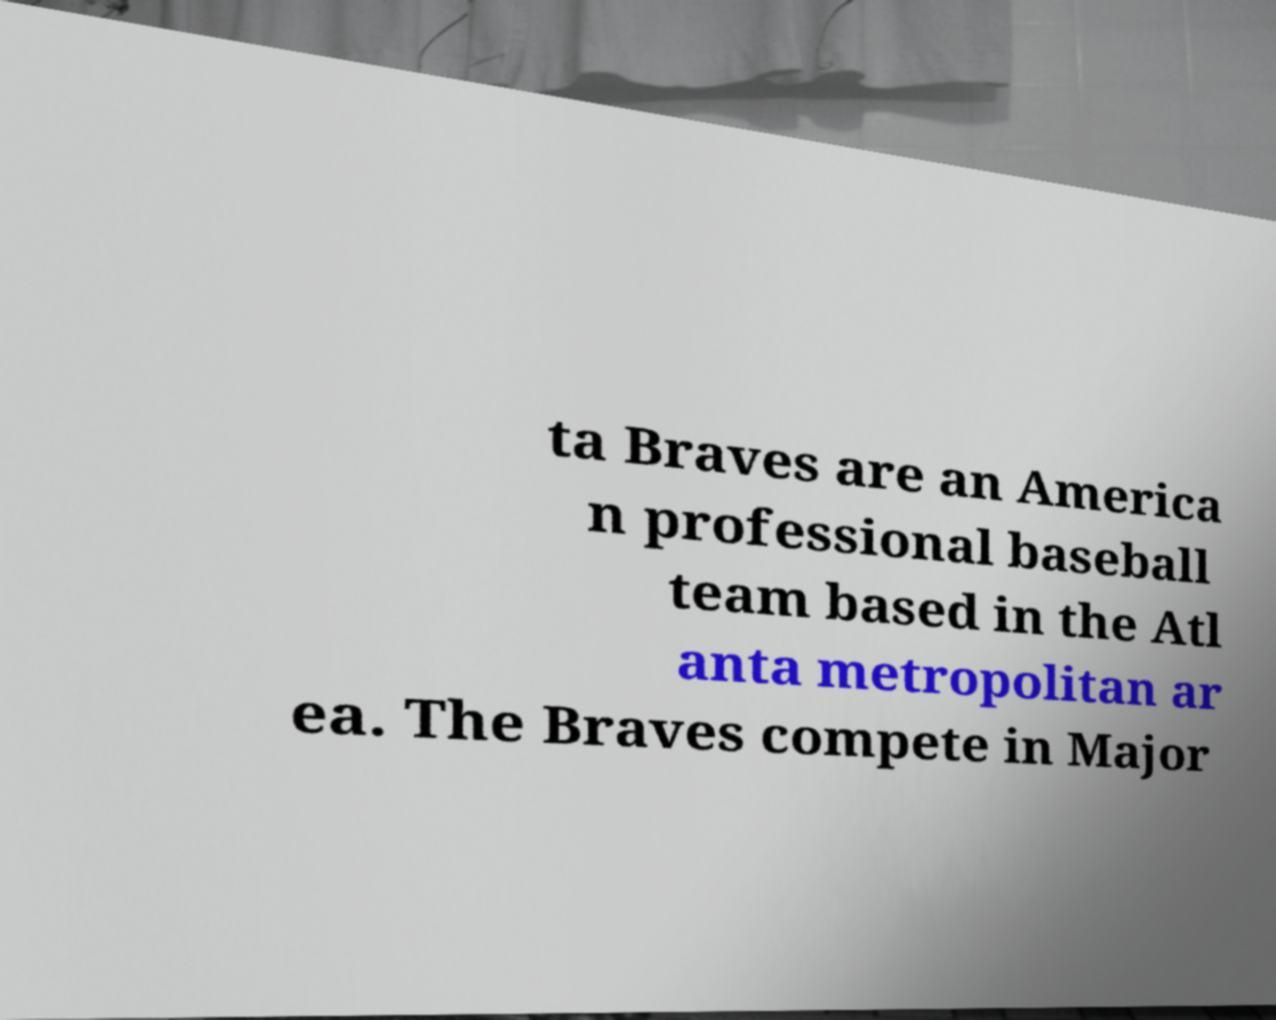For documentation purposes, I need the text within this image transcribed. Could you provide that? ta Braves are an America n professional baseball team based in the Atl anta metropolitan ar ea. The Braves compete in Major 